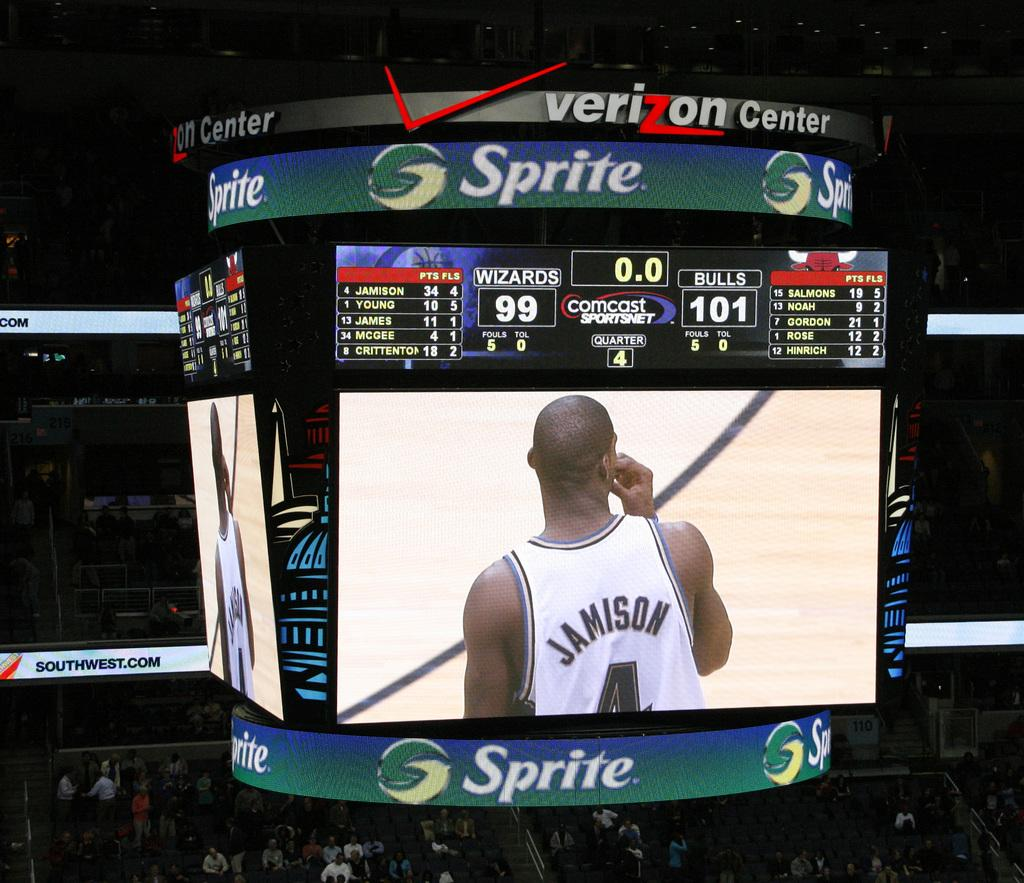<image>
Describe the image concisely. Basketball scoreboard with the score 99-101 between the Wizards and Bulls 